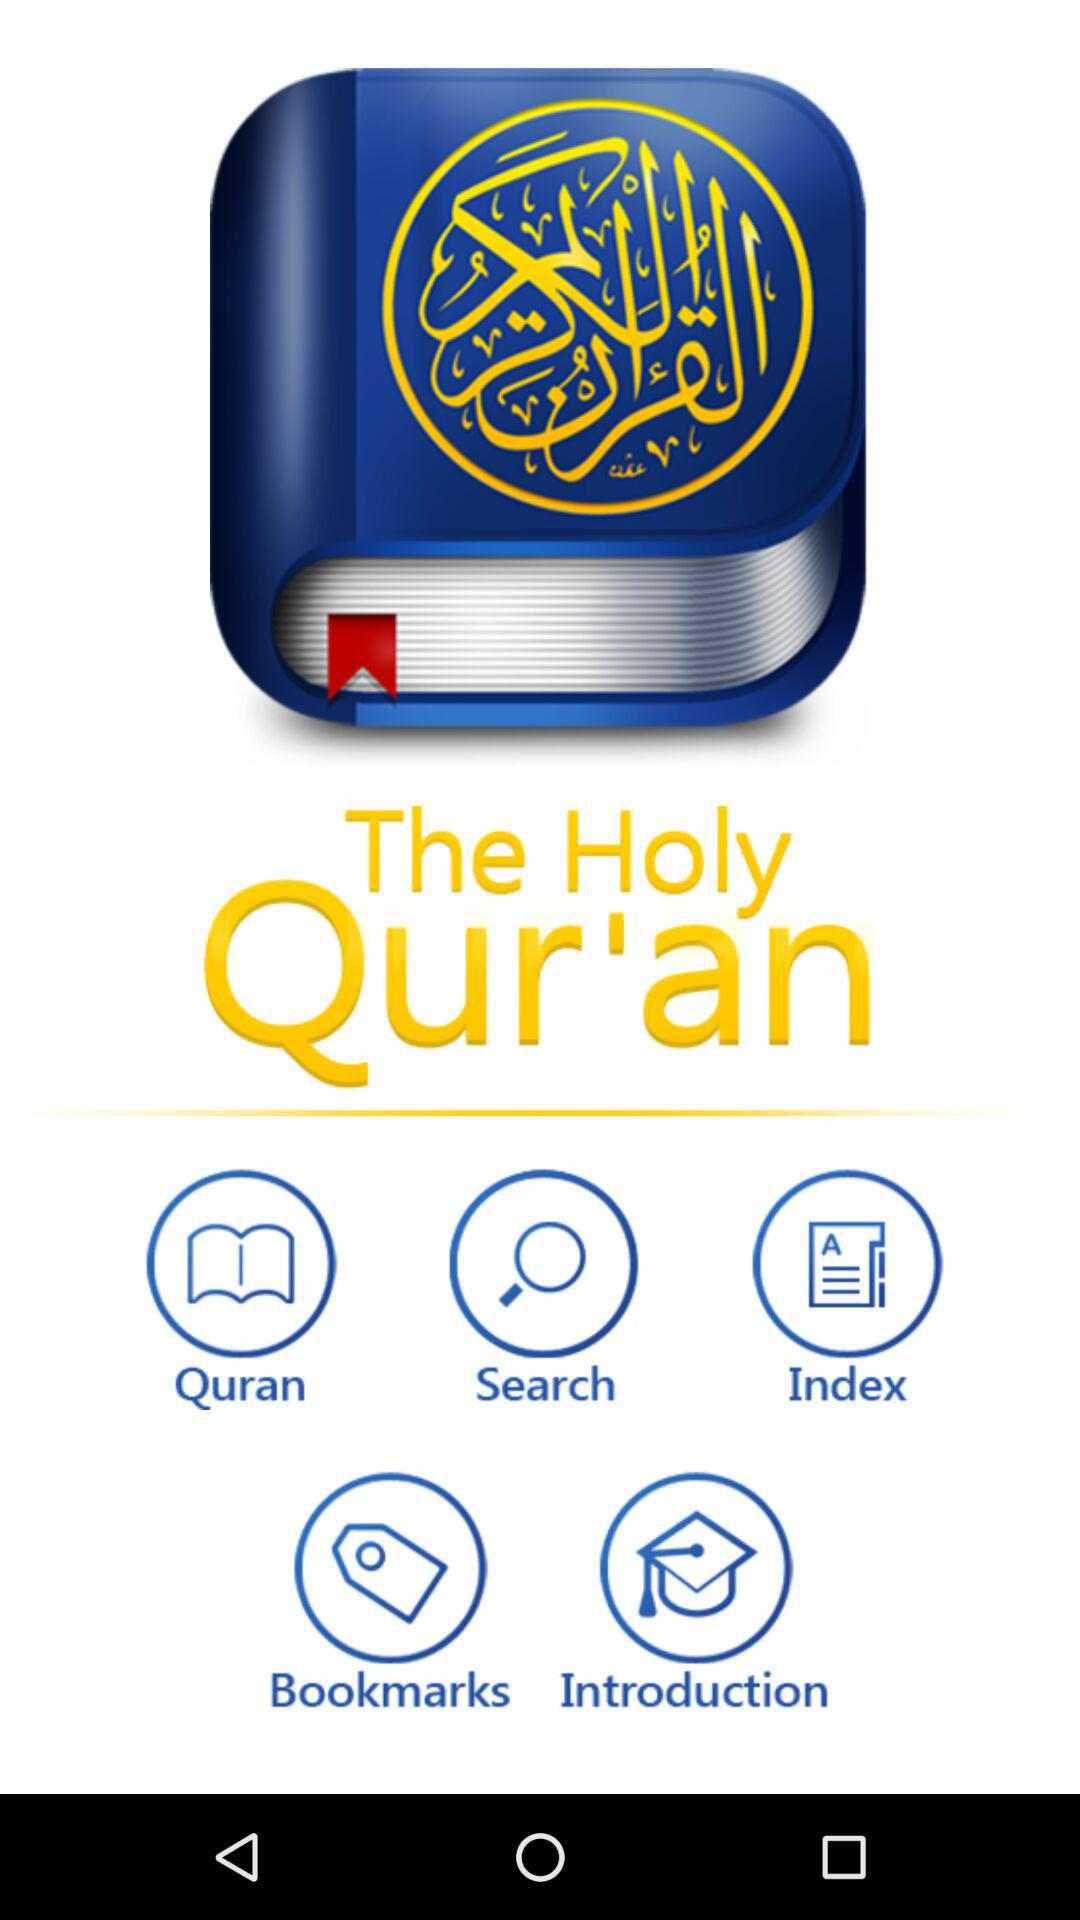What is the application name? The application name is "The Holy Qur'an". 